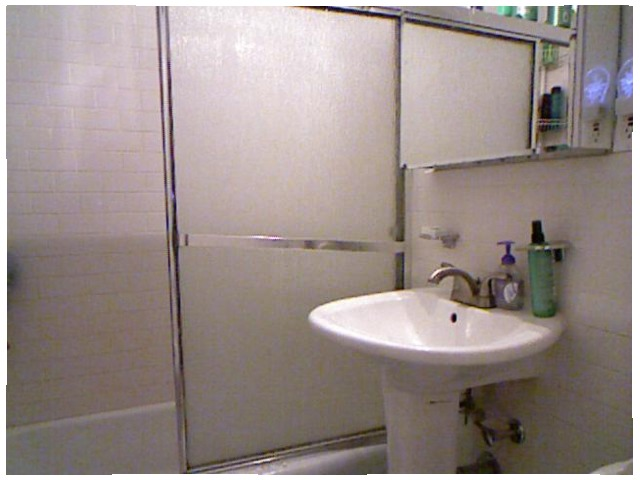<image>
Is there a soap next to the faucet? Yes. The soap is positioned adjacent to the faucet, located nearby in the same general area. 